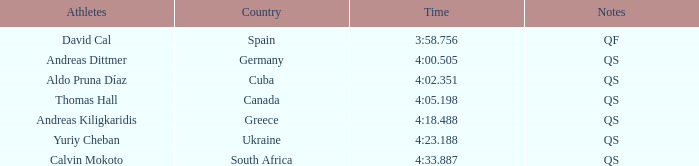What position does andreas kiligkaridis hold in the ranking? 5.0. 